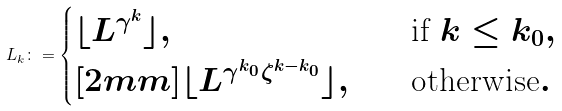Convert formula to latex. <formula><loc_0><loc_0><loc_500><loc_500>L _ { k } \colon = \begin{cases} \lfloor L ^ { \gamma ^ { k } } \rfloor , \quad & \text {if } k \leq k _ { 0 } , \\ [ 2 m m ] \lfloor L ^ { \gamma ^ { k _ { 0 } } \zeta ^ { k - k _ { 0 } } } \rfloor , \quad & \text {otherwise} . \end{cases}</formula> 